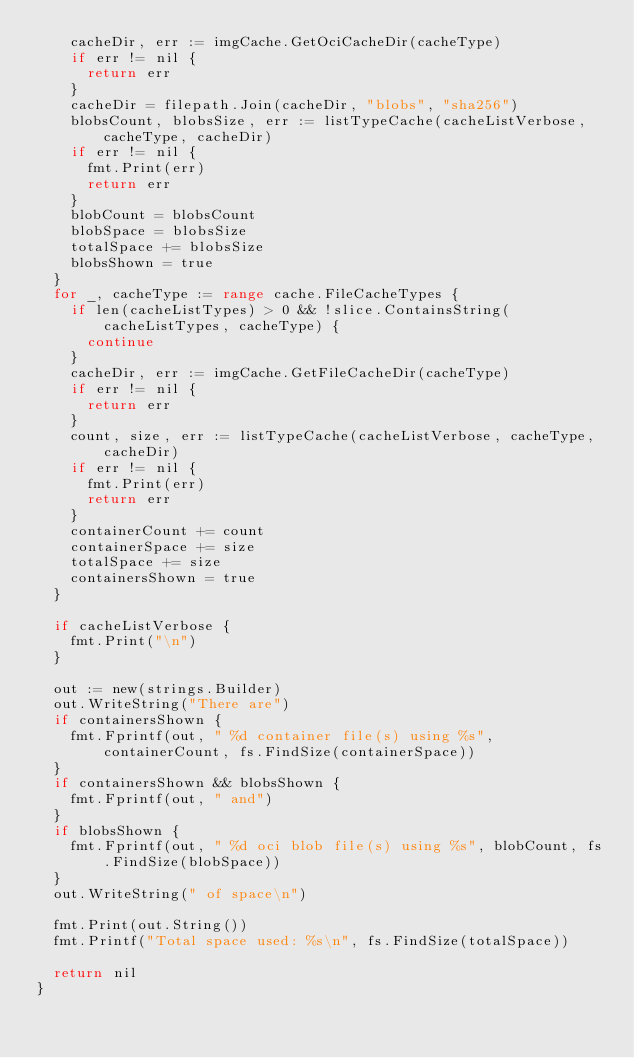Convert code to text. <code><loc_0><loc_0><loc_500><loc_500><_Go_>		cacheDir, err := imgCache.GetOciCacheDir(cacheType)
		if err != nil {
			return err
		}
		cacheDir = filepath.Join(cacheDir, "blobs", "sha256")
		blobsCount, blobsSize, err := listTypeCache(cacheListVerbose, cacheType, cacheDir)
		if err != nil {
			fmt.Print(err)
			return err
		}
		blobCount = blobsCount
		blobSpace = blobsSize
		totalSpace += blobsSize
		blobsShown = true
	}
	for _, cacheType := range cache.FileCacheTypes {
		if len(cacheListTypes) > 0 && !slice.ContainsString(cacheListTypes, cacheType) {
			continue
		}
		cacheDir, err := imgCache.GetFileCacheDir(cacheType)
		if err != nil {
			return err
		}
		count, size, err := listTypeCache(cacheListVerbose, cacheType, cacheDir)
		if err != nil {
			fmt.Print(err)
			return err
		}
		containerCount += count
		containerSpace += size
		totalSpace += size
		containersShown = true
	}

	if cacheListVerbose {
		fmt.Print("\n")
	}

	out := new(strings.Builder)
	out.WriteString("There are")
	if containersShown {
		fmt.Fprintf(out, " %d container file(s) using %s", containerCount, fs.FindSize(containerSpace))
	}
	if containersShown && blobsShown {
		fmt.Fprintf(out, " and")
	}
	if blobsShown {
		fmt.Fprintf(out, " %d oci blob file(s) using %s", blobCount, fs.FindSize(blobSpace))
	}
	out.WriteString(" of space\n")

	fmt.Print(out.String())
	fmt.Printf("Total space used: %s\n", fs.FindSize(totalSpace))

	return nil
}
</code> 